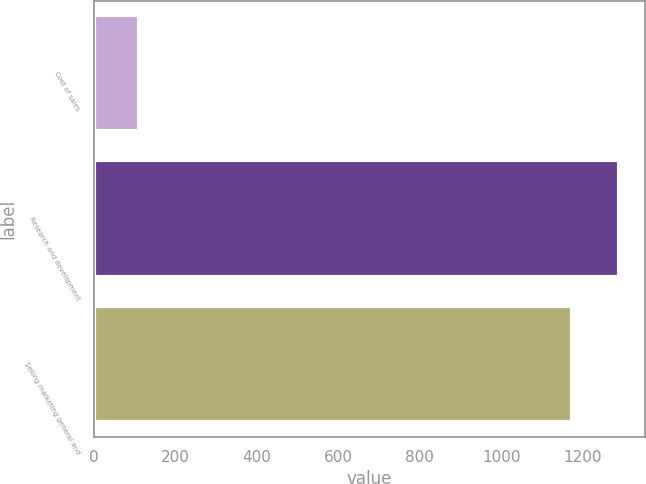Convert chart to OTSL. <chart><loc_0><loc_0><loc_500><loc_500><bar_chart><fcel>Cost of sales<fcel>Research and development<fcel>Selling marketing general and<nl><fcel>112<fcel>1288.7<fcel>1174<nl></chart> 